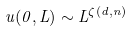<formula> <loc_0><loc_0><loc_500><loc_500>u ( 0 , L ) \sim L ^ { \zeta ( d , n ) }</formula> 